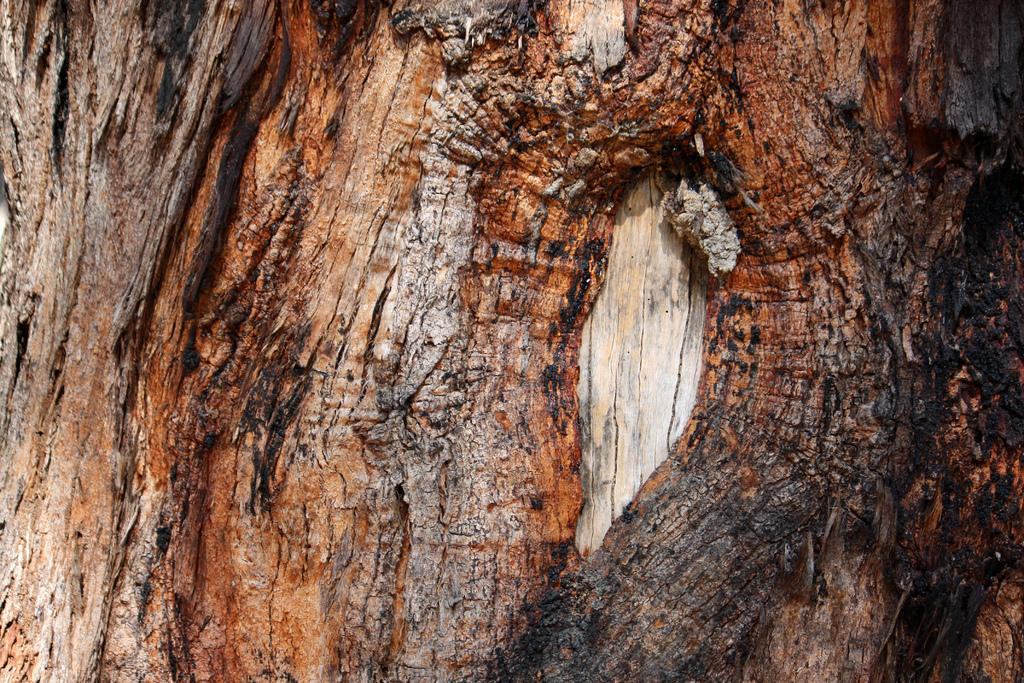What is the main subject of the image? The main subject of the image is tree bark. What colors can be seen on the tree bark? The tree bark has brown, red, and black colors. What type of reaction does the tree bark have when exposed to sunlight? There is no information about the tree bark's reaction to sunlight in the image, so it cannot be determined. 